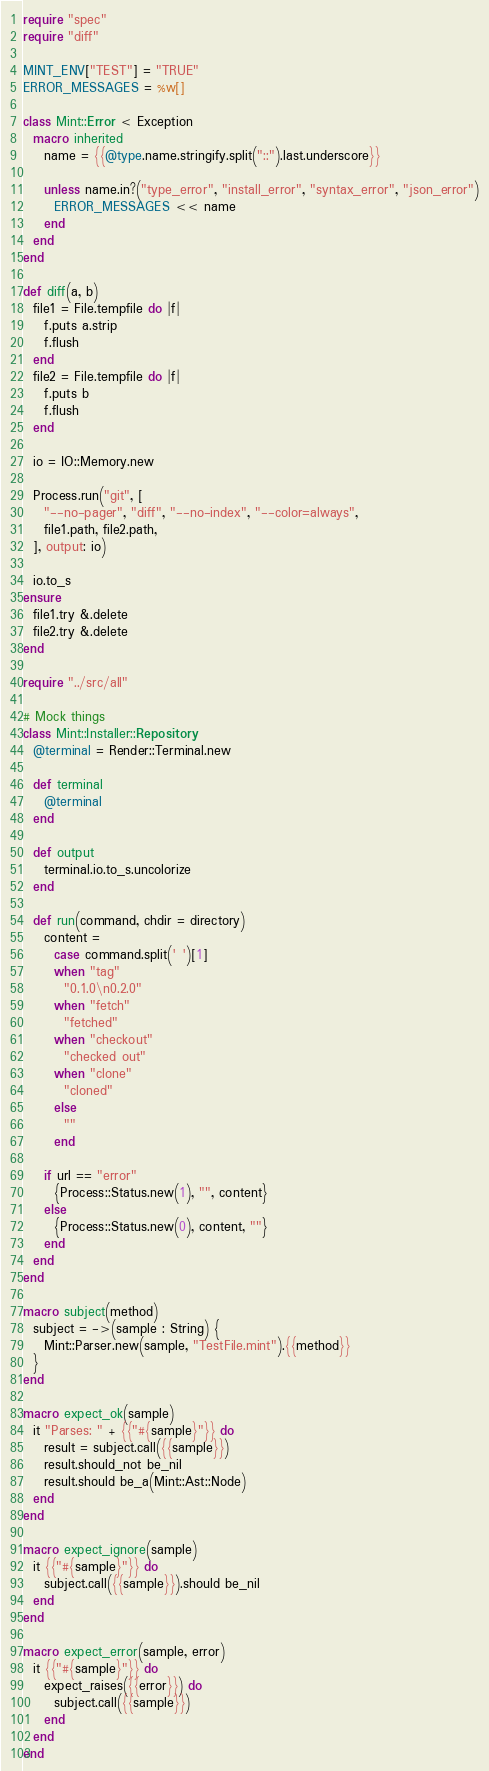Convert code to text. <code><loc_0><loc_0><loc_500><loc_500><_Crystal_>require "spec"
require "diff"

MINT_ENV["TEST"] = "TRUE"
ERROR_MESSAGES = %w[]

class Mint::Error < Exception
  macro inherited
    name = {{@type.name.stringify.split("::").last.underscore}}

    unless name.in?("type_error", "install_error", "syntax_error", "json_error")
      ERROR_MESSAGES << name
    end
  end
end

def diff(a, b)
  file1 = File.tempfile do |f|
    f.puts a.strip
    f.flush
  end
  file2 = File.tempfile do |f|
    f.puts b
    f.flush
  end

  io = IO::Memory.new

  Process.run("git", [
    "--no-pager", "diff", "--no-index", "--color=always",
    file1.path, file2.path,
  ], output: io)

  io.to_s
ensure
  file1.try &.delete
  file2.try &.delete
end

require "../src/all"

# Mock things
class Mint::Installer::Repository
  @terminal = Render::Terminal.new

  def terminal
    @terminal
  end

  def output
    terminal.io.to_s.uncolorize
  end

  def run(command, chdir = directory)
    content =
      case command.split(' ')[1]
      when "tag"
        "0.1.0\n0.2.0"
      when "fetch"
        "fetched"
      when "checkout"
        "checked out"
      when "clone"
        "cloned"
      else
        ""
      end

    if url == "error"
      {Process::Status.new(1), "", content}
    else
      {Process::Status.new(0), content, ""}
    end
  end
end

macro subject(method)
  subject = ->(sample : String) {
    Mint::Parser.new(sample, "TestFile.mint").{{method}}
  }
end

macro expect_ok(sample)
  it "Parses: " + {{"#{sample}"}} do
    result = subject.call({{sample}})
    result.should_not be_nil
    result.should be_a(Mint::Ast::Node)
  end
end

macro expect_ignore(sample)
  it {{"#{sample}"}} do
    subject.call({{sample}}).should be_nil
  end
end

macro expect_error(sample, error)
  it {{"#{sample}"}} do
    expect_raises({{error}}) do
      subject.call({{sample}})
    end
  end
end
</code> 